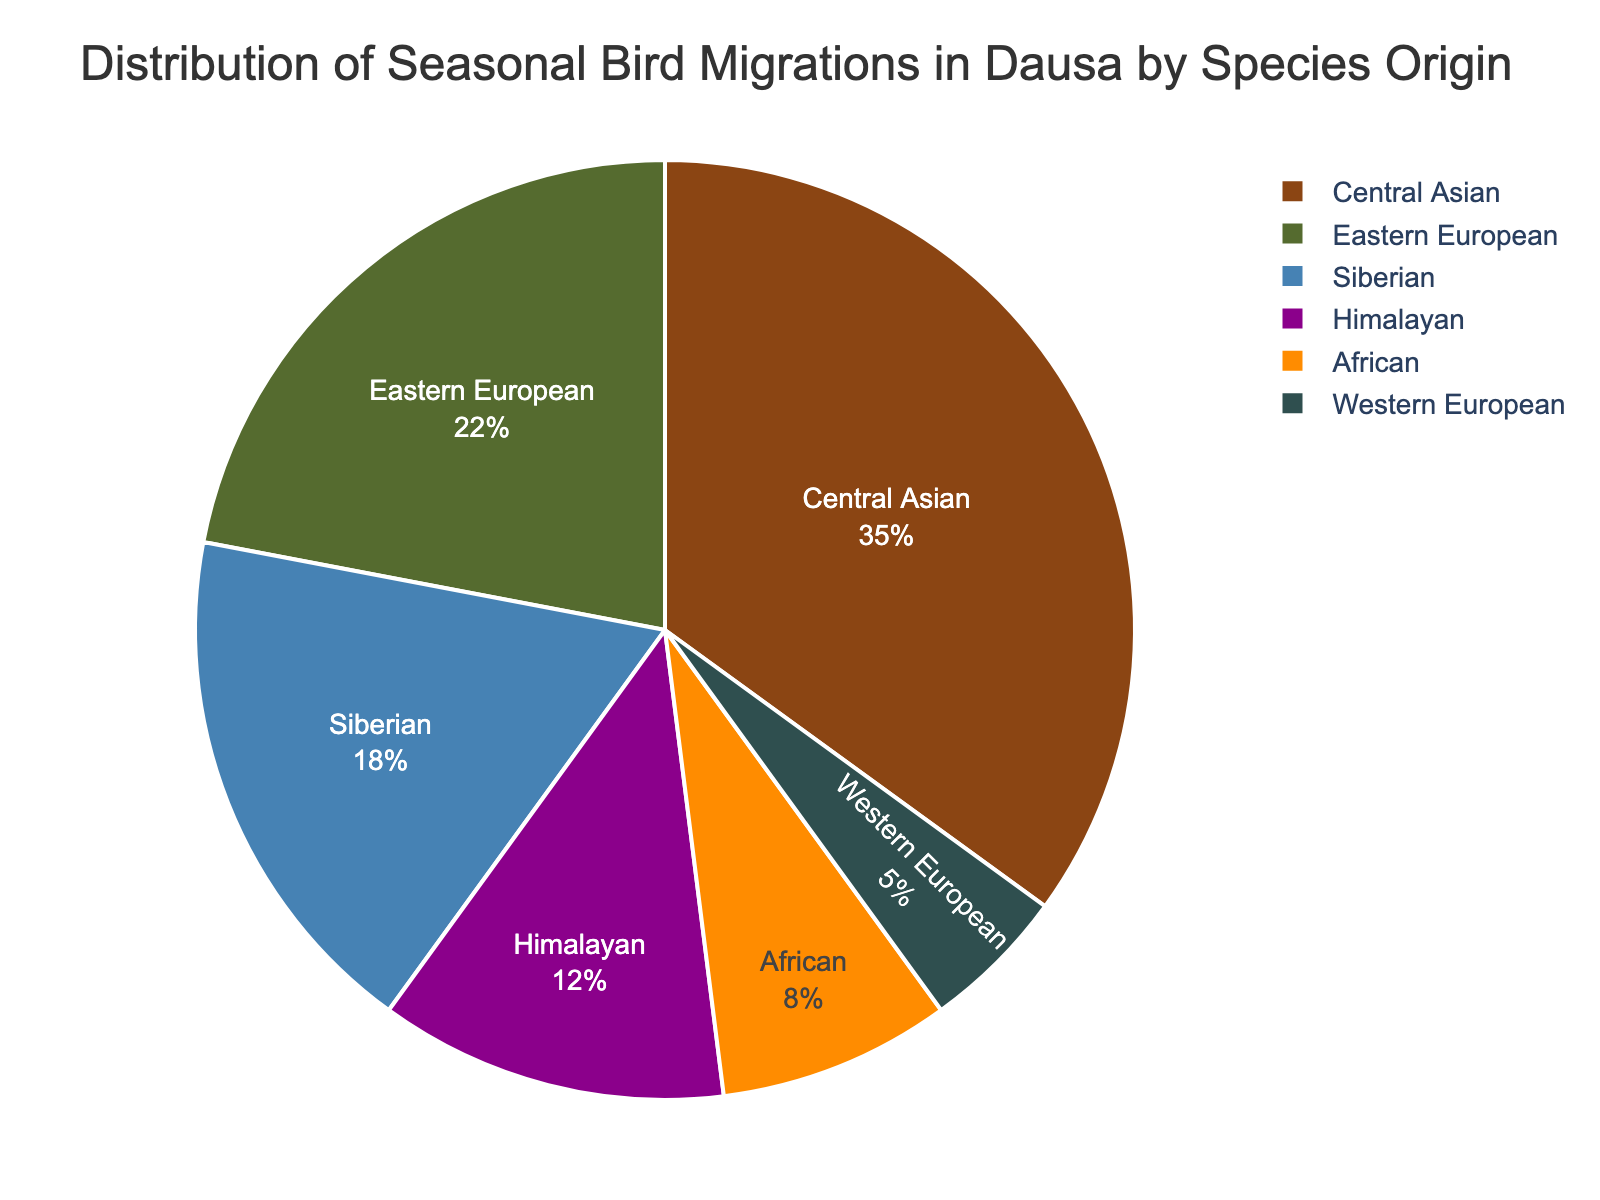What's the largest group of migrating birds based on their origin? The figure shows that the Central Asian species have the largest segment of the pie chart, indicating they make up the highest percentage of migrating birds.
Answer: Central Asian Which group has the smallest portion of bird migrations? The smallest segment in the pie chart corresponds to Western European species, making up the smallest percentage of migrating birds.
Answer: Western European What is the combined percentage of bird migrations from African and Western European origins? Add the percentages of the African (8%) and Western European (5%) segments: 8% + 5% = 13%.
Answer: 13% Are there more birds migrating to Dausa from Central Asia or from a combination of Himalayan and Eastern European origins? Compare the percentage of Central Asian birds (35%) with the sum of Himalayan (12%) and Eastern European (22%) birds: 12% + 22% = 34%. Since 35% > 34%, there are more Central Asian birds migrating.
Answer: Central Asian How much greater is the migration percentage from Central Asian species compared to Siberian species? Subtract the percentage of Siberian species (18%) from the Central Asian species (35%): 35% - 18% = 17%.
Answer: 17% What percentage of migrating birds come from the Himalayas and Africa combined? Add the percentages of Himalayan (12%) and African (8%) segments: 12% + 8% = 20%.
Answer: 20% Which two origins together make up the majority of bird migrations in Dausa? Determine which two segments sum to more than 50%. The Central Asian (35%) and Eastern European (22%) segments together make up 35% + 22% = 57%, which is more than half of the total.
Answer: Central Asian and Eastern European Is the percentage of bird migrations from Siberia more than double the percentage from Western Europe? Compare double the percentage of Western European birds (5% × 2 = 10%) with the percentage of Siberian birds (18%). Since 18% > 10%, the percentage from Siberia is more than double.
Answer: Yes Which species origin contributes more: Himalayans or Siberians? Compare the percentages of Himalayan (12%) and Siberian (18%) segments. Since 18% > 12%, more migrations come from Siberian species.
Answer: Siberians What's the difference in the migration percentage between the African and Himalayan species? Subtract the percentage of African species (8%) from the Himalayan species (12%): 12% - 8% = 4%.
Answer: 4% 